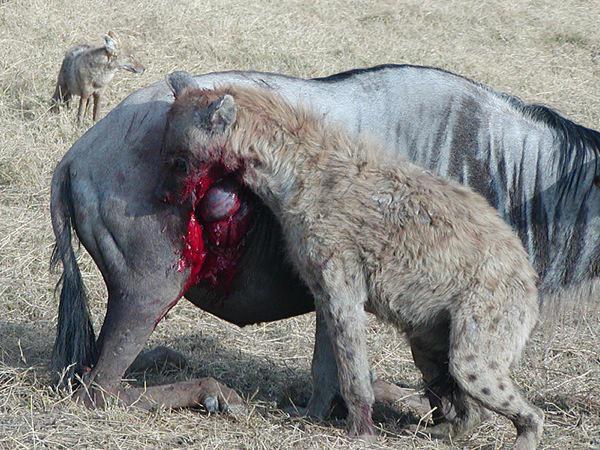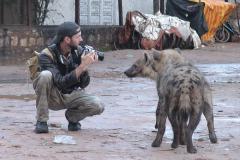The first image is the image on the left, the second image is the image on the right. Evaluate the accuracy of this statement regarding the images: "The hyena in the foreground of the left image is walking forward at a rightward angle with its head lowered and one front paw off the ground and bent inward.". Is it true? Answer yes or no. No. 